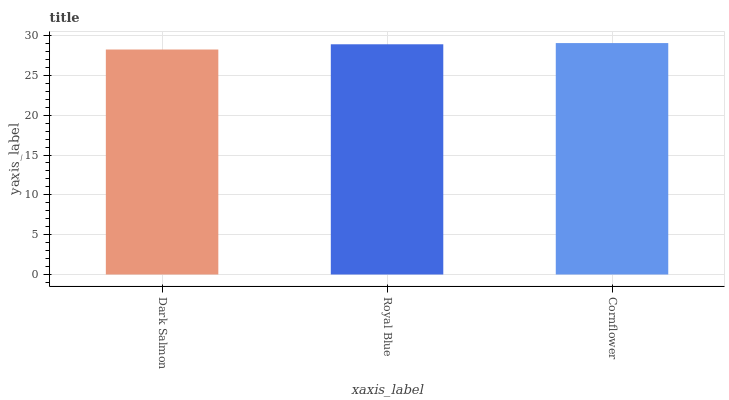Is Dark Salmon the minimum?
Answer yes or no. Yes. Is Cornflower the maximum?
Answer yes or no. Yes. Is Royal Blue the minimum?
Answer yes or no. No. Is Royal Blue the maximum?
Answer yes or no. No. Is Royal Blue greater than Dark Salmon?
Answer yes or no. Yes. Is Dark Salmon less than Royal Blue?
Answer yes or no. Yes. Is Dark Salmon greater than Royal Blue?
Answer yes or no. No. Is Royal Blue less than Dark Salmon?
Answer yes or no. No. Is Royal Blue the high median?
Answer yes or no. Yes. Is Royal Blue the low median?
Answer yes or no. Yes. Is Dark Salmon the high median?
Answer yes or no. No. Is Dark Salmon the low median?
Answer yes or no. No. 